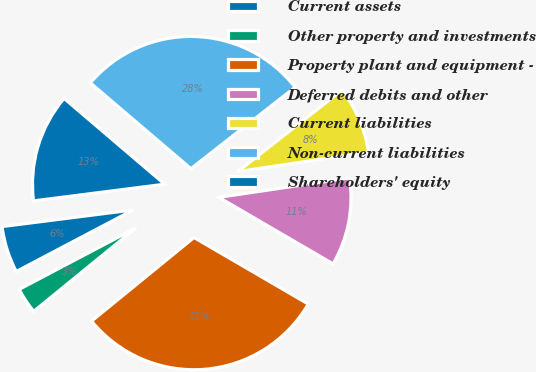Convert chart to OTSL. <chart><loc_0><loc_0><loc_500><loc_500><pie_chart><fcel>Current assets<fcel>Other property and investments<fcel>Property plant and equipment -<fcel>Deferred debits and other<fcel>Current liabilities<fcel>Non-current liabilities<fcel>Shareholders' equity<nl><fcel>5.7%<fcel>3.18%<fcel>30.71%<fcel>10.73%<fcel>8.22%<fcel>28.2%<fcel>13.25%<nl></chart> 